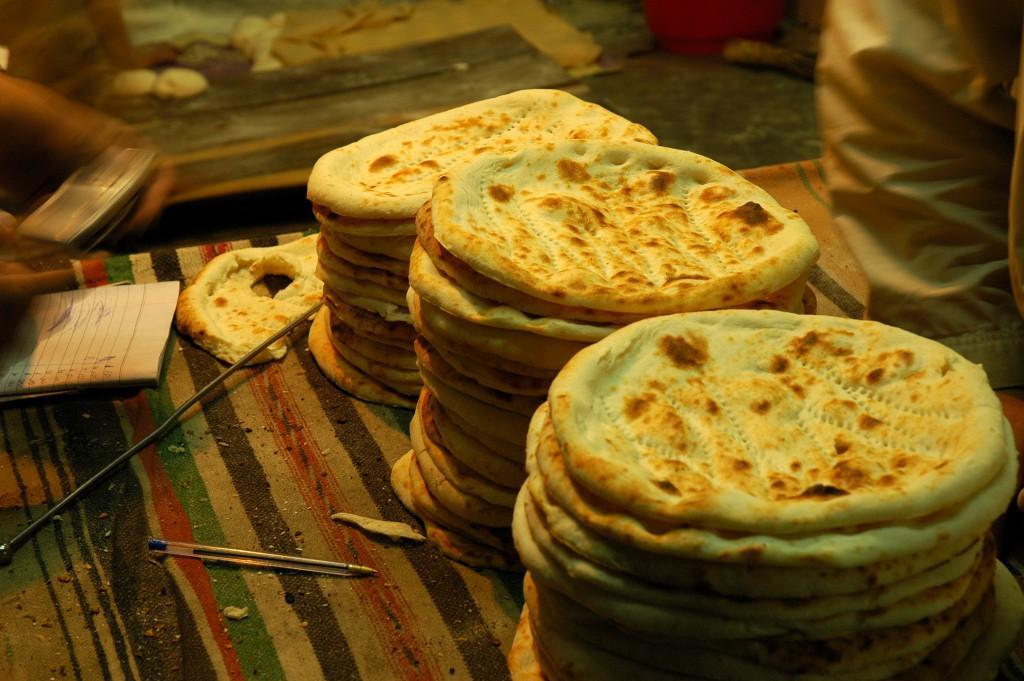Can you describe this image briefly? In this image we can see flatbreads on a surface. Also there is a book, pen. In the background it is blur. And we can see hand of a person on the right side. 